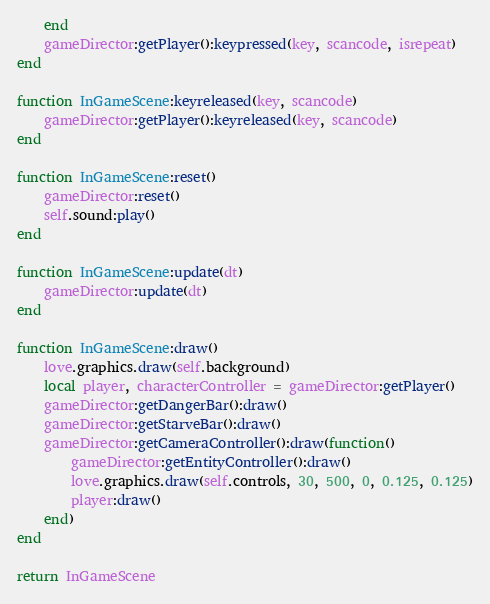<code> <loc_0><loc_0><loc_500><loc_500><_Lua_>    end
    gameDirector:getPlayer():keypressed(key, scancode, isrepeat)
end

function InGameScene:keyreleased(key, scancode)
    gameDirector:getPlayer():keyreleased(key, scancode)
end

function InGameScene:reset()
    gameDirector:reset()
    self.sound:play()
end

function InGameScene:update(dt)
    gameDirector:update(dt)
end

function InGameScene:draw()
    love.graphics.draw(self.background)
    local player, characterController = gameDirector:getPlayer()
    gameDirector:getDangerBar():draw()
    gameDirector:getStarveBar():draw()
    gameDirector:getCameraController():draw(function()
        gameDirector:getEntityController():draw()
        love.graphics.draw(self.controls, 30, 500, 0, 0.125, 0.125)
        player:draw()
    end)
end

return InGameScene
</code> 